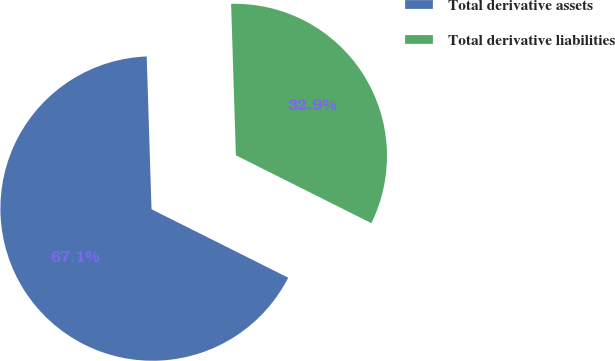Convert chart to OTSL. <chart><loc_0><loc_0><loc_500><loc_500><pie_chart><fcel>Total derivative assets<fcel>Total derivative liabilities<nl><fcel>67.11%<fcel>32.89%<nl></chart> 